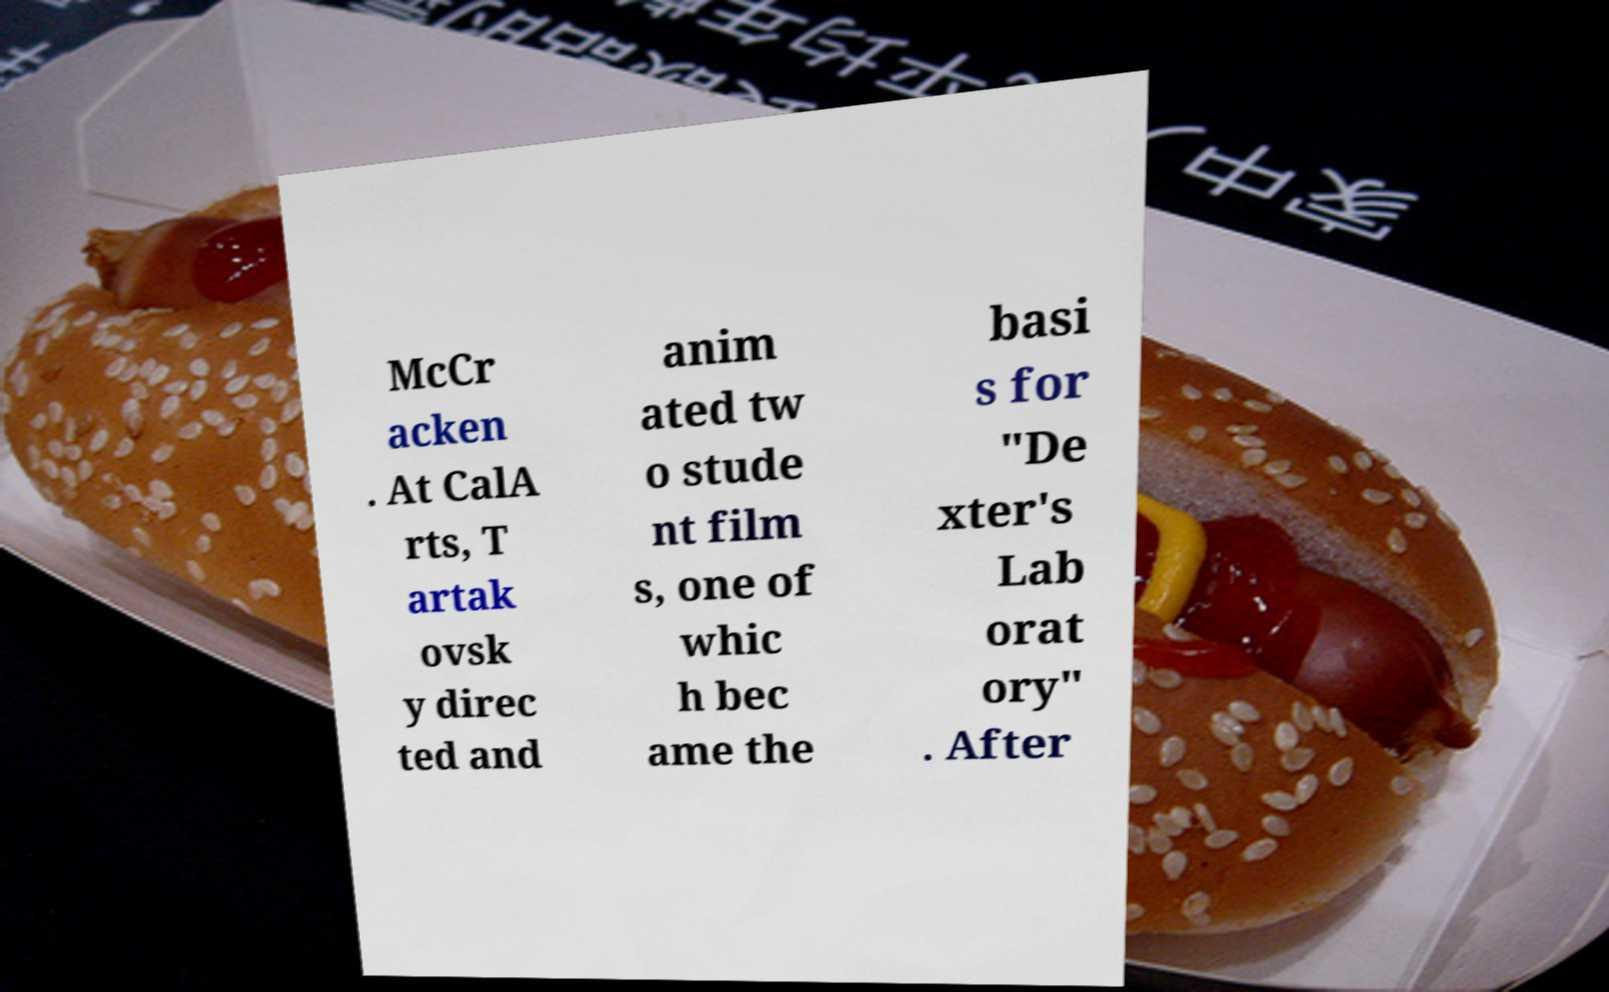There's text embedded in this image that I need extracted. Can you transcribe it verbatim? McCr acken . At CalA rts, T artak ovsk y direc ted and anim ated tw o stude nt film s, one of whic h bec ame the basi s for "De xter's Lab orat ory" . After 